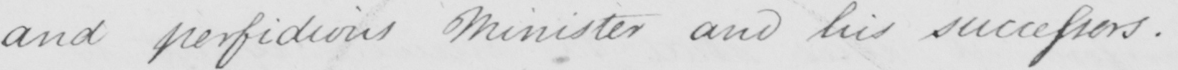Please transcribe the handwritten text in this image. and perfidious Minister and his successors.- 